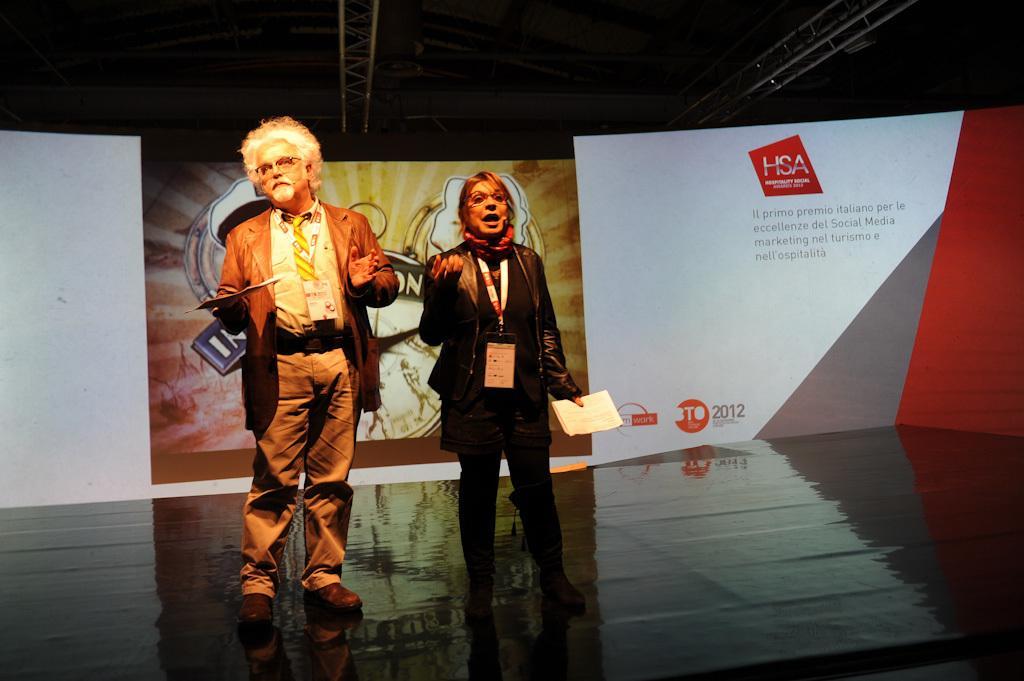Can you describe this image briefly? In this image we can see a man and a lady standing on the stage and holding papers in their hands. In the background there are boards. At the top there is a roof. 